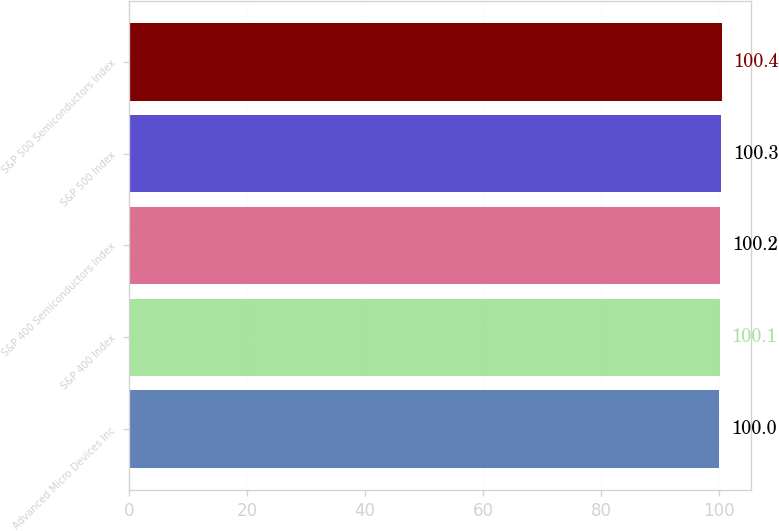Convert chart to OTSL. <chart><loc_0><loc_0><loc_500><loc_500><bar_chart><fcel>Advanced Micro Devices Inc<fcel>S&P 400 Index<fcel>S&P 400 Semiconductors Index<fcel>S&P 500 Index<fcel>S&P 500 Semiconductors Index<nl><fcel>100<fcel>100.1<fcel>100.2<fcel>100.3<fcel>100.4<nl></chart> 